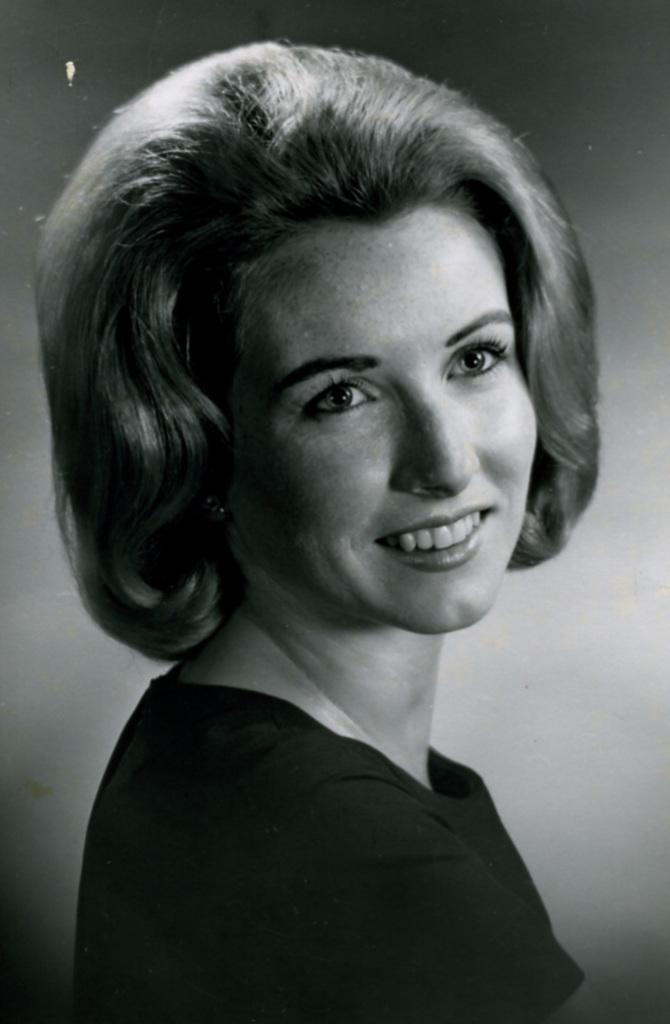In one or two sentences, can you explain what this image depicts? This is a black and white image. In this image we can see a lady smiling. In the back there is a wall. 